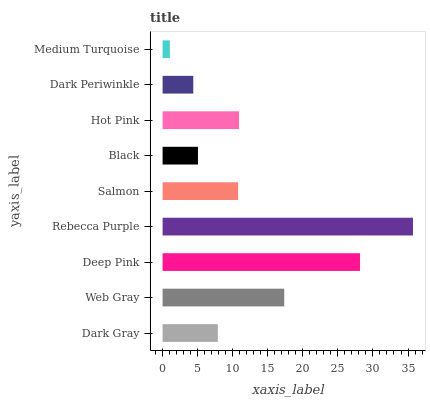Is Medium Turquoise the minimum?
Answer yes or no. Yes. Is Rebecca Purple the maximum?
Answer yes or no. Yes. Is Web Gray the minimum?
Answer yes or no. No. Is Web Gray the maximum?
Answer yes or no. No. Is Web Gray greater than Dark Gray?
Answer yes or no. Yes. Is Dark Gray less than Web Gray?
Answer yes or no. Yes. Is Dark Gray greater than Web Gray?
Answer yes or no. No. Is Web Gray less than Dark Gray?
Answer yes or no. No. Is Salmon the high median?
Answer yes or no. Yes. Is Salmon the low median?
Answer yes or no. Yes. Is Rebecca Purple the high median?
Answer yes or no. No. Is Web Gray the low median?
Answer yes or no. No. 